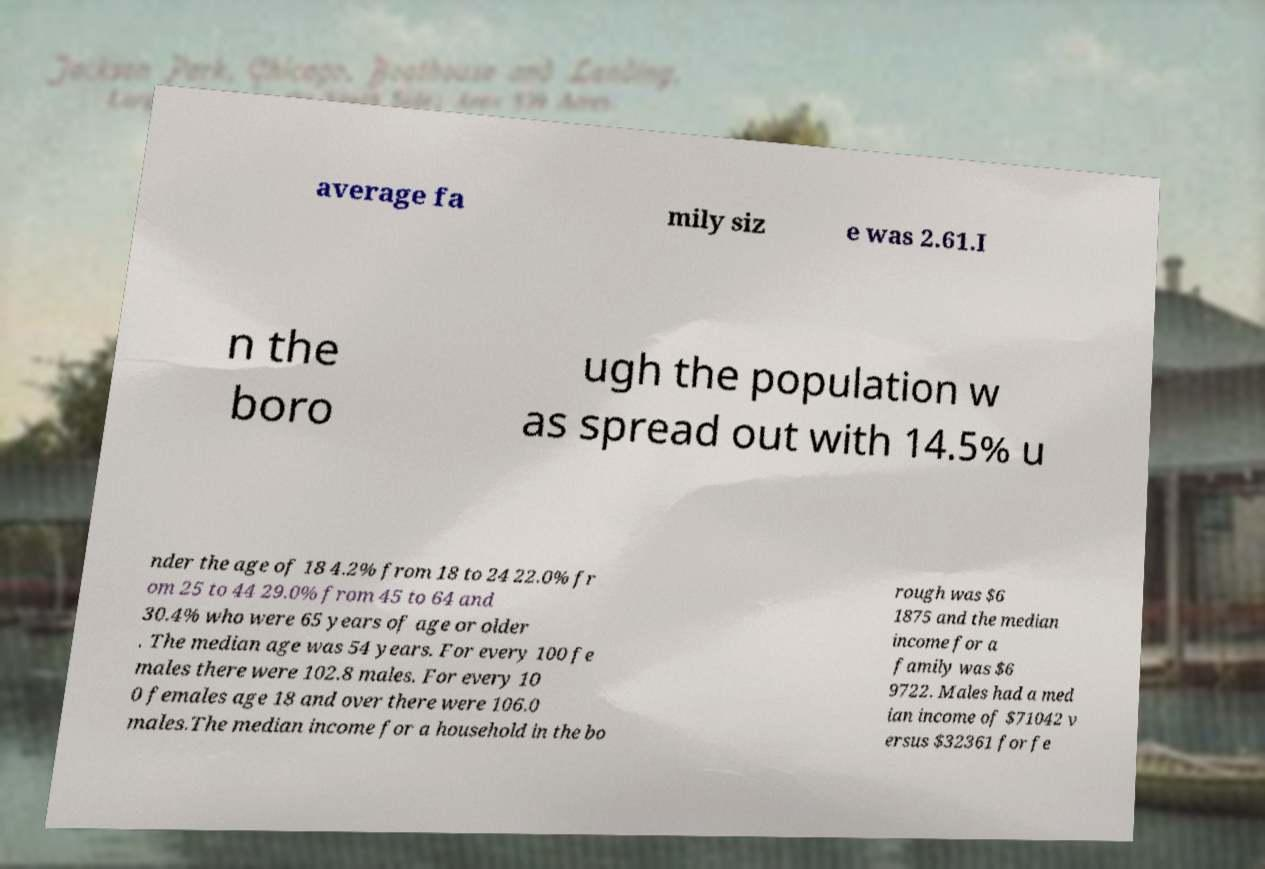Can you read and provide the text displayed in the image?This photo seems to have some interesting text. Can you extract and type it out for me? average fa mily siz e was 2.61.I n the boro ugh the population w as spread out with 14.5% u nder the age of 18 4.2% from 18 to 24 22.0% fr om 25 to 44 29.0% from 45 to 64 and 30.4% who were 65 years of age or older . The median age was 54 years. For every 100 fe males there were 102.8 males. For every 10 0 females age 18 and over there were 106.0 males.The median income for a household in the bo rough was $6 1875 and the median income for a family was $6 9722. Males had a med ian income of $71042 v ersus $32361 for fe 